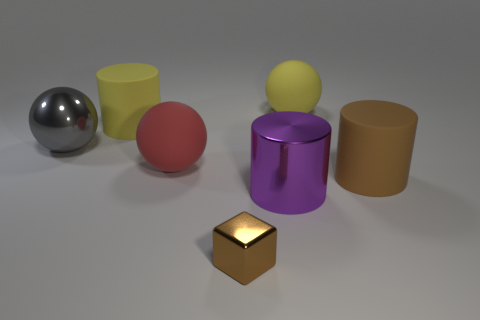There is a yellow rubber thing on the left side of the red matte sphere; is its size the same as the tiny metallic cube?
Give a very brief answer. No. What is the material of the gray object that is the same shape as the large red rubber object?
Provide a succinct answer. Metal. There is a rubber cylinder that is the same color as the tiny object; what size is it?
Your answer should be very brief. Large. There is a brown thing that is on the left side of the big purple thing; what is its size?
Provide a succinct answer. Small. There is a large rubber object that is the same color as the metallic block; what shape is it?
Make the answer very short. Cylinder. There is a metal thing that is on the left side of the large cylinder to the left of the big metallic cylinder left of the brown matte cylinder; what is its shape?
Give a very brief answer. Sphere. What number of other things are there of the same shape as the small brown object?
Offer a terse response. 0. How many metal objects are either brown cubes or large cyan objects?
Offer a very short reply. 1. What is the yellow thing to the left of the big ball behind the big gray metallic thing made of?
Offer a terse response. Rubber. Is the number of red rubber things in front of the yellow rubber ball greater than the number of tiny purple metal cylinders?
Give a very brief answer. Yes. 